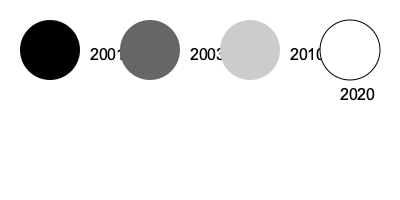Based on the evolution of Wikipedia's logo shown above, what color scheme is likely to be used for the logo in 2030 if the trend continues? To answer this question, we need to analyze the pattern in Wikipedia's logo evolution:

1. In 2001, the logo was solid black.
2. In 2003, it changed to a dark gray (#666666).
3. In 2010, it became a light gray (#CCCCCC).
4. In 2020, the logo became white with a black outline.

The pattern shows a gradual lightening of the logo color:
- From black (2001) to dark gray (2003)
- From dark gray (2003) to light gray (2010)
- From light gray (2010) to white with black outline (2020)

If this trend continues, the next logical step would be to remove the black outline, leaving just a white or transparent logo. This would complete the progression from solid dark to completely light/transparent.
Answer: Transparent or white (without outline) 